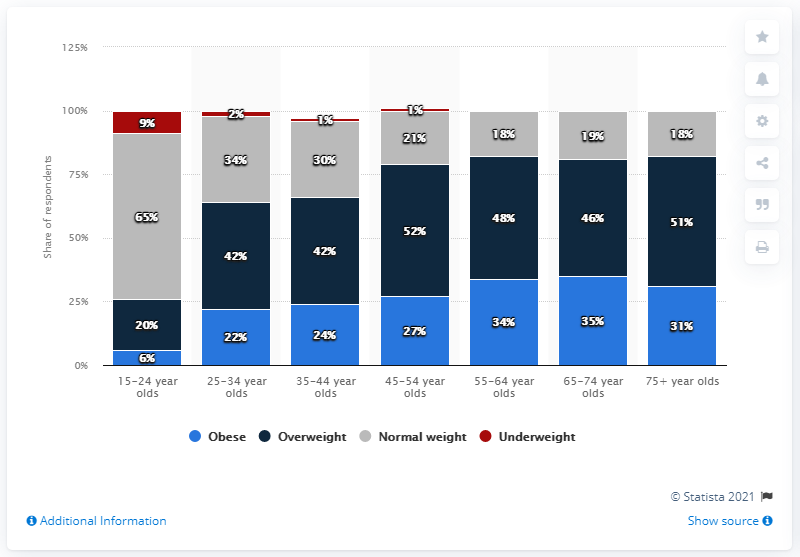Identify some key points in this picture. Out of the three categories, none of them have underweight individuals. The ratio between obese individuals aged 25-34 and 35-44 is 0.916666667, indicating that for every 100 obese individuals aged 25-34, there are 91.67 obese individuals aged 35-44. 